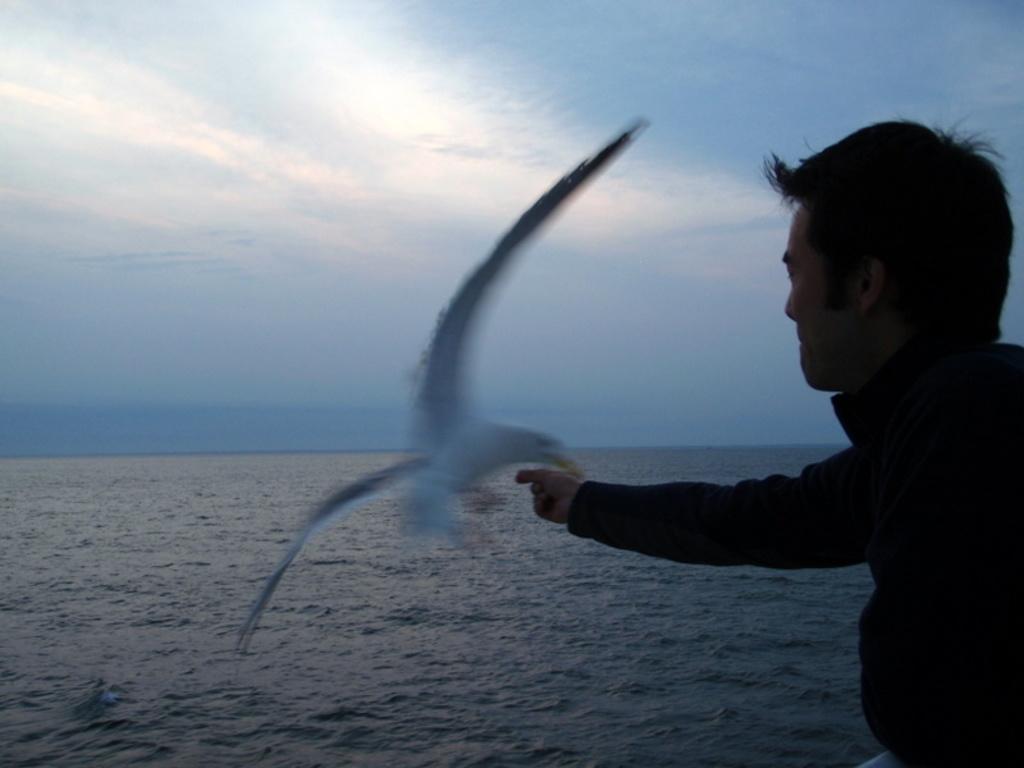Please provide a concise description of this image. In this image there is a person feeding a bird as we can see on the right side of this image. There is a bird in the middle of this image. There is a sea in the bottom of this image and there is a sky on the top of this image. 